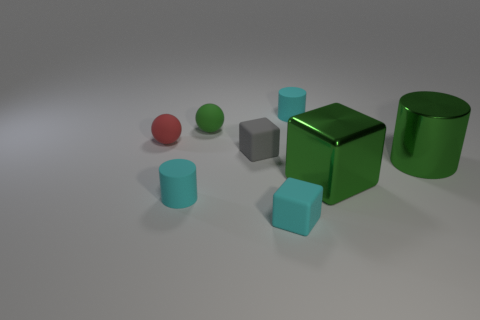Subtract all brown balls. How many cyan cylinders are left? 2 Subtract 1 cylinders. How many cylinders are left? 2 Subtract all tiny cubes. How many cubes are left? 1 Add 2 small red cylinders. How many objects exist? 10 Subtract all spheres. How many objects are left? 6 Subtract all large green shiny cylinders. Subtract all tiny cyan matte cubes. How many objects are left? 6 Add 4 tiny spheres. How many tiny spheres are left? 6 Add 5 tiny green spheres. How many tiny green spheres exist? 6 Subtract 0 brown cylinders. How many objects are left? 8 